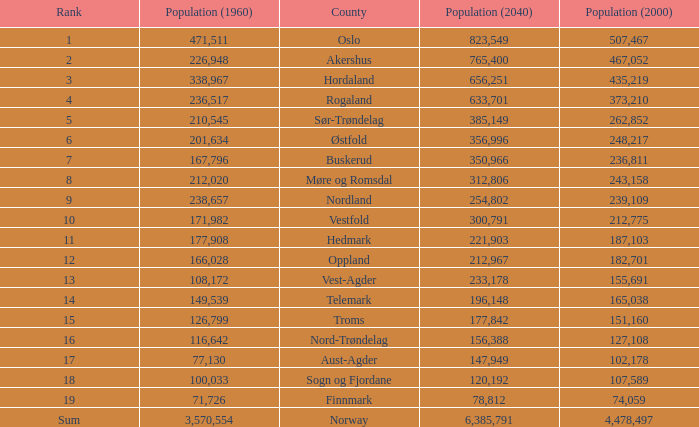What was the population of a county in 2040 that had a population less than 108,172 in 2000 and less than 107,589 in 1960? 2.0. 